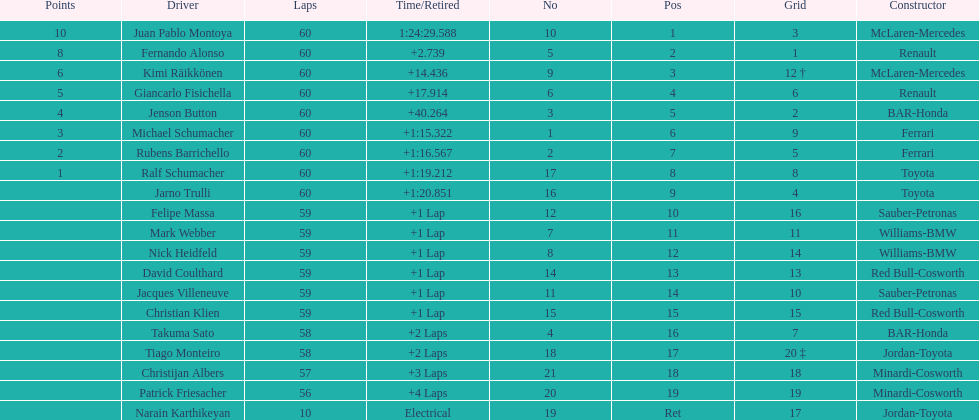Whose grid is set at number 2 among the drivers? Jenson Button. 